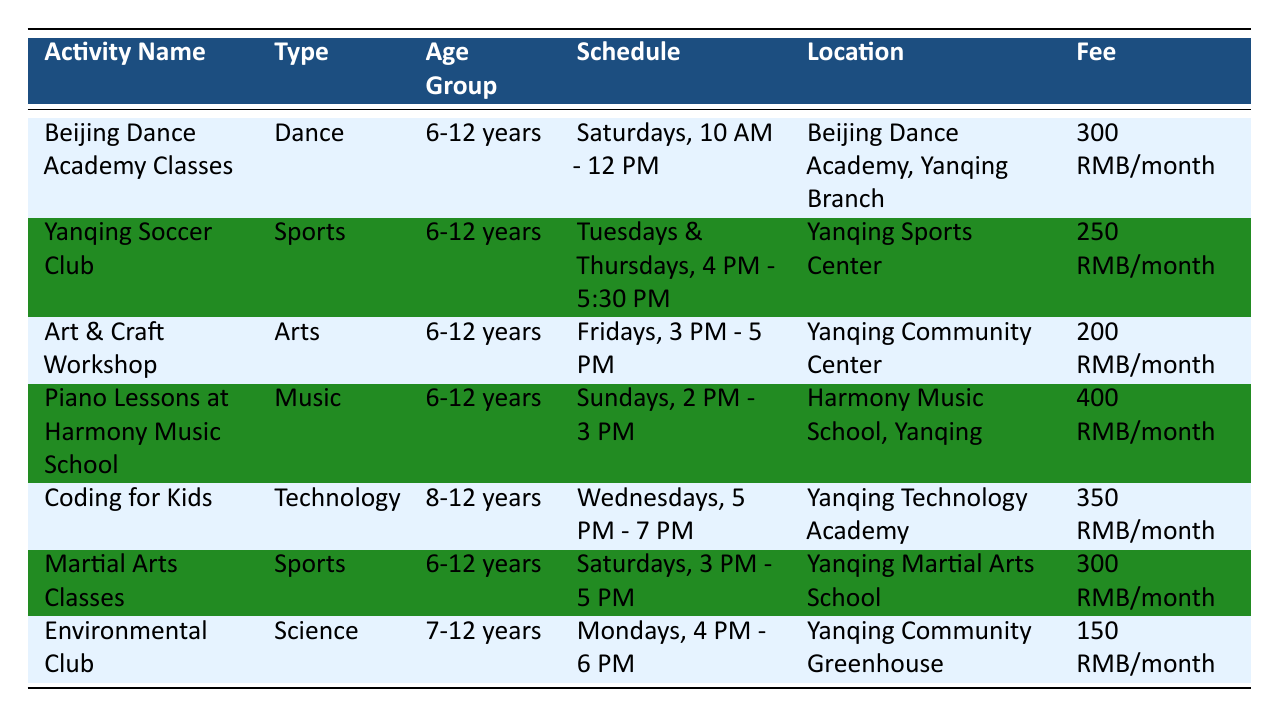What is the fee for the Art & Craft Workshop? The fee for the Art & Craft Workshop is listed in the table under the "Fee" column for this specific activity. The fee is 200 RMB/month.
Answer: 200 RMB/month What day and time are the piano lessons scheduled? The scheduled day and time for piano lessons can be found in the "Schedule" column next to the activity name. It is on Sundays from 2 PM to 3 PM.
Answer: Sundays, 2 PM - 3 PM Are the Yanqing Soccer Club activities held on weekends? To determine if the Yanqing Soccer Club activities are held on weekends, we check the "Schedule" column for this activity. It shows the activities are on Tuesdays and Thursdays, which are not weekends.
Answer: No How many sports activities are listed in the table? The sports activities can be counted from the "Type" column. The activities listed as Sports are Yanqing Soccer Club and Martial Arts Classes, making a total of 2 sports activities.
Answer: 2 What is the average fee of all the extracurricular activities? We sum all the fees provided: 300 + 250 + 200 + 400 + 350 + 300 + 150 = 1950 RMB. Then, we divide this total by the number of activities, which is 7. So, the average fee is 1950/7 = 278.57 RMB, rounded to two decimal places.
Answer: 278.57 RMB Is there an activity specifically designed for children aged 12 years? To answer this question, we look for activities listed under the "Age Group" column that specifically include 12 years. The activities that cater to the age group 6-12 years can include children who are 12 years old as well, so yes, there are activities for 12-year-olds.
Answer: Yes Which activity has the earliest starting time in the week? We need to examine the "Schedule" column for each activity to identify their starting times. The earliest time found is 10 AM on Saturdays for the Beijing Dance Academy Classes.
Answer: Beijing Dance Academy Classes Which activity has the largest age range? To find the largest age range, we compare the age groups in the "Age Group" column. The Coding for Kids has the age group of 8-12 years, while other activities vary between 6-12 and 7-12. Therefore, the largest range is from 6 to 12 years.
Answer: 6-12 years 